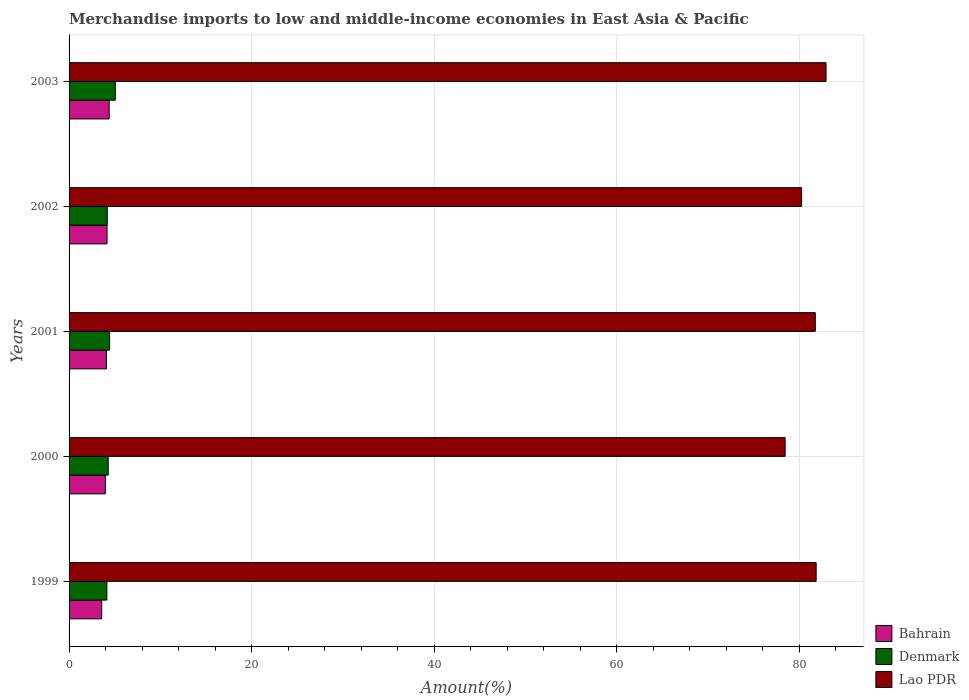How many different coloured bars are there?
Your response must be concise. 3. How many groups of bars are there?
Offer a very short reply. 5. Are the number of bars per tick equal to the number of legend labels?
Provide a short and direct response. Yes. How many bars are there on the 1st tick from the top?
Keep it short and to the point. 3. How many bars are there on the 2nd tick from the bottom?
Your answer should be very brief. 3. What is the percentage of amount earned from merchandise imports in Denmark in 2001?
Offer a terse response. 4.44. Across all years, what is the maximum percentage of amount earned from merchandise imports in Lao PDR?
Your response must be concise. 82.91. Across all years, what is the minimum percentage of amount earned from merchandise imports in Lao PDR?
Ensure brevity in your answer.  78.43. What is the total percentage of amount earned from merchandise imports in Denmark in the graph?
Your answer should be compact. 22.12. What is the difference between the percentage of amount earned from merchandise imports in Denmark in 2001 and that in 2002?
Provide a succinct answer. 0.26. What is the difference between the percentage of amount earned from merchandise imports in Denmark in 2003 and the percentage of amount earned from merchandise imports in Bahrain in 2002?
Provide a succinct answer. 0.91. What is the average percentage of amount earned from merchandise imports in Bahrain per year?
Offer a terse response. 4.04. In the year 1999, what is the difference between the percentage of amount earned from merchandise imports in Bahrain and percentage of amount earned from merchandise imports in Denmark?
Make the answer very short. -0.57. What is the ratio of the percentage of amount earned from merchandise imports in Bahrain in 2002 to that in 2003?
Make the answer very short. 0.95. Is the percentage of amount earned from merchandise imports in Lao PDR in 1999 less than that in 2003?
Keep it short and to the point. Yes. What is the difference between the highest and the second highest percentage of amount earned from merchandise imports in Bahrain?
Your answer should be very brief. 0.23. What is the difference between the highest and the lowest percentage of amount earned from merchandise imports in Bahrain?
Offer a terse response. 0.82. In how many years, is the percentage of amount earned from merchandise imports in Bahrain greater than the average percentage of amount earned from merchandise imports in Bahrain taken over all years?
Make the answer very short. 3. What does the 2nd bar from the top in 1999 represents?
Make the answer very short. Denmark. What does the 3rd bar from the bottom in 2002 represents?
Your answer should be very brief. Lao PDR. Are all the bars in the graph horizontal?
Your answer should be very brief. Yes. What is the difference between two consecutive major ticks on the X-axis?
Provide a short and direct response. 20. Are the values on the major ticks of X-axis written in scientific E-notation?
Offer a very short reply. No. How many legend labels are there?
Ensure brevity in your answer.  3. What is the title of the graph?
Make the answer very short. Merchandise imports to low and middle-income economies in East Asia & Pacific. What is the label or title of the X-axis?
Give a very brief answer. Amount(%). What is the Amount(%) of Bahrain in 1999?
Your answer should be compact. 3.57. What is the Amount(%) in Denmark in 1999?
Provide a succinct answer. 4.14. What is the Amount(%) of Lao PDR in 1999?
Give a very brief answer. 81.83. What is the Amount(%) in Bahrain in 2000?
Your response must be concise. 3.97. What is the Amount(%) in Denmark in 2000?
Make the answer very short. 4.29. What is the Amount(%) of Lao PDR in 2000?
Provide a short and direct response. 78.43. What is the Amount(%) of Bahrain in 2001?
Your answer should be very brief. 4.09. What is the Amount(%) of Denmark in 2001?
Provide a short and direct response. 4.44. What is the Amount(%) in Lao PDR in 2001?
Ensure brevity in your answer.  81.73. What is the Amount(%) in Bahrain in 2002?
Provide a short and direct response. 4.16. What is the Amount(%) of Denmark in 2002?
Provide a succinct answer. 4.18. What is the Amount(%) in Lao PDR in 2002?
Your answer should be compact. 80.23. What is the Amount(%) of Bahrain in 2003?
Offer a terse response. 4.39. What is the Amount(%) in Denmark in 2003?
Your answer should be very brief. 5.06. What is the Amount(%) in Lao PDR in 2003?
Your response must be concise. 82.91. Across all years, what is the maximum Amount(%) in Bahrain?
Offer a very short reply. 4.39. Across all years, what is the maximum Amount(%) of Denmark?
Your answer should be compact. 5.06. Across all years, what is the maximum Amount(%) of Lao PDR?
Offer a very short reply. 82.91. Across all years, what is the minimum Amount(%) in Bahrain?
Your response must be concise. 3.57. Across all years, what is the minimum Amount(%) in Denmark?
Your answer should be very brief. 4.14. Across all years, what is the minimum Amount(%) in Lao PDR?
Provide a short and direct response. 78.43. What is the total Amount(%) in Bahrain in the graph?
Your answer should be compact. 20.18. What is the total Amount(%) of Denmark in the graph?
Provide a succinct answer. 22.12. What is the total Amount(%) in Lao PDR in the graph?
Give a very brief answer. 405.13. What is the difference between the Amount(%) of Bahrain in 1999 and that in 2000?
Keep it short and to the point. -0.4. What is the difference between the Amount(%) in Denmark in 1999 and that in 2000?
Provide a succinct answer. -0.15. What is the difference between the Amount(%) in Lao PDR in 1999 and that in 2000?
Your answer should be compact. 3.4. What is the difference between the Amount(%) of Bahrain in 1999 and that in 2001?
Your answer should be very brief. -0.52. What is the difference between the Amount(%) in Denmark in 1999 and that in 2001?
Offer a very short reply. -0.3. What is the difference between the Amount(%) in Lao PDR in 1999 and that in 2001?
Keep it short and to the point. 0.09. What is the difference between the Amount(%) in Bahrain in 1999 and that in 2002?
Offer a terse response. -0.59. What is the difference between the Amount(%) of Denmark in 1999 and that in 2002?
Your response must be concise. -0.04. What is the difference between the Amount(%) in Lao PDR in 1999 and that in 2002?
Your answer should be very brief. 1.6. What is the difference between the Amount(%) of Bahrain in 1999 and that in 2003?
Your response must be concise. -0.82. What is the difference between the Amount(%) in Denmark in 1999 and that in 2003?
Your response must be concise. -0.92. What is the difference between the Amount(%) in Lao PDR in 1999 and that in 2003?
Your answer should be very brief. -1.08. What is the difference between the Amount(%) of Bahrain in 2000 and that in 2001?
Make the answer very short. -0.12. What is the difference between the Amount(%) in Denmark in 2000 and that in 2001?
Make the answer very short. -0.15. What is the difference between the Amount(%) in Lao PDR in 2000 and that in 2001?
Your answer should be compact. -3.31. What is the difference between the Amount(%) in Bahrain in 2000 and that in 2002?
Your response must be concise. -0.19. What is the difference between the Amount(%) of Denmark in 2000 and that in 2002?
Provide a short and direct response. 0.1. What is the difference between the Amount(%) in Lao PDR in 2000 and that in 2002?
Provide a succinct answer. -1.8. What is the difference between the Amount(%) in Bahrain in 2000 and that in 2003?
Provide a short and direct response. -0.42. What is the difference between the Amount(%) of Denmark in 2000 and that in 2003?
Your response must be concise. -0.78. What is the difference between the Amount(%) in Lao PDR in 2000 and that in 2003?
Make the answer very short. -4.48. What is the difference between the Amount(%) in Bahrain in 2001 and that in 2002?
Keep it short and to the point. -0.06. What is the difference between the Amount(%) in Denmark in 2001 and that in 2002?
Offer a very short reply. 0.26. What is the difference between the Amount(%) of Lao PDR in 2001 and that in 2002?
Provide a succinct answer. 1.5. What is the difference between the Amount(%) of Bahrain in 2001 and that in 2003?
Make the answer very short. -0.3. What is the difference between the Amount(%) in Denmark in 2001 and that in 2003?
Offer a very short reply. -0.62. What is the difference between the Amount(%) in Lao PDR in 2001 and that in 2003?
Ensure brevity in your answer.  -1.18. What is the difference between the Amount(%) in Bahrain in 2002 and that in 2003?
Offer a very short reply. -0.23. What is the difference between the Amount(%) of Denmark in 2002 and that in 2003?
Give a very brief answer. -0.88. What is the difference between the Amount(%) in Lao PDR in 2002 and that in 2003?
Your answer should be compact. -2.68. What is the difference between the Amount(%) of Bahrain in 1999 and the Amount(%) of Denmark in 2000?
Offer a terse response. -0.72. What is the difference between the Amount(%) in Bahrain in 1999 and the Amount(%) in Lao PDR in 2000?
Provide a succinct answer. -74.86. What is the difference between the Amount(%) of Denmark in 1999 and the Amount(%) of Lao PDR in 2000?
Provide a short and direct response. -74.29. What is the difference between the Amount(%) in Bahrain in 1999 and the Amount(%) in Denmark in 2001?
Provide a short and direct response. -0.87. What is the difference between the Amount(%) of Bahrain in 1999 and the Amount(%) of Lao PDR in 2001?
Offer a terse response. -78.16. What is the difference between the Amount(%) in Denmark in 1999 and the Amount(%) in Lao PDR in 2001?
Provide a short and direct response. -77.59. What is the difference between the Amount(%) of Bahrain in 1999 and the Amount(%) of Denmark in 2002?
Make the answer very short. -0.61. What is the difference between the Amount(%) in Bahrain in 1999 and the Amount(%) in Lao PDR in 2002?
Your answer should be compact. -76.66. What is the difference between the Amount(%) in Denmark in 1999 and the Amount(%) in Lao PDR in 2002?
Keep it short and to the point. -76.09. What is the difference between the Amount(%) in Bahrain in 1999 and the Amount(%) in Denmark in 2003?
Keep it short and to the point. -1.49. What is the difference between the Amount(%) in Bahrain in 1999 and the Amount(%) in Lao PDR in 2003?
Keep it short and to the point. -79.34. What is the difference between the Amount(%) in Denmark in 1999 and the Amount(%) in Lao PDR in 2003?
Provide a succinct answer. -78.77. What is the difference between the Amount(%) in Bahrain in 2000 and the Amount(%) in Denmark in 2001?
Offer a very short reply. -0.47. What is the difference between the Amount(%) in Bahrain in 2000 and the Amount(%) in Lao PDR in 2001?
Your answer should be very brief. -77.76. What is the difference between the Amount(%) of Denmark in 2000 and the Amount(%) of Lao PDR in 2001?
Your response must be concise. -77.45. What is the difference between the Amount(%) of Bahrain in 2000 and the Amount(%) of Denmark in 2002?
Give a very brief answer. -0.21. What is the difference between the Amount(%) in Bahrain in 2000 and the Amount(%) in Lao PDR in 2002?
Provide a short and direct response. -76.26. What is the difference between the Amount(%) of Denmark in 2000 and the Amount(%) of Lao PDR in 2002?
Offer a very short reply. -75.94. What is the difference between the Amount(%) of Bahrain in 2000 and the Amount(%) of Denmark in 2003?
Provide a short and direct response. -1.09. What is the difference between the Amount(%) in Bahrain in 2000 and the Amount(%) in Lao PDR in 2003?
Make the answer very short. -78.94. What is the difference between the Amount(%) in Denmark in 2000 and the Amount(%) in Lao PDR in 2003?
Give a very brief answer. -78.62. What is the difference between the Amount(%) of Bahrain in 2001 and the Amount(%) of Denmark in 2002?
Offer a very short reply. -0.09. What is the difference between the Amount(%) of Bahrain in 2001 and the Amount(%) of Lao PDR in 2002?
Ensure brevity in your answer.  -76.14. What is the difference between the Amount(%) of Denmark in 2001 and the Amount(%) of Lao PDR in 2002?
Make the answer very short. -75.79. What is the difference between the Amount(%) of Bahrain in 2001 and the Amount(%) of Denmark in 2003?
Provide a short and direct response. -0.97. What is the difference between the Amount(%) of Bahrain in 2001 and the Amount(%) of Lao PDR in 2003?
Your answer should be very brief. -78.82. What is the difference between the Amount(%) of Denmark in 2001 and the Amount(%) of Lao PDR in 2003?
Your answer should be very brief. -78.47. What is the difference between the Amount(%) in Bahrain in 2002 and the Amount(%) in Denmark in 2003?
Ensure brevity in your answer.  -0.91. What is the difference between the Amount(%) of Bahrain in 2002 and the Amount(%) of Lao PDR in 2003?
Provide a succinct answer. -78.75. What is the difference between the Amount(%) in Denmark in 2002 and the Amount(%) in Lao PDR in 2003?
Provide a short and direct response. -78.73. What is the average Amount(%) of Bahrain per year?
Keep it short and to the point. 4.04. What is the average Amount(%) of Denmark per year?
Provide a succinct answer. 4.42. What is the average Amount(%) of Lao PDR per year?
Ensure brevity in your answer.  81.03. In the year 1999, what is the difference between the Amount(%) in Bahrain and Amount(%) in Denmark?
Offer a terse response. -0.57. In the year 1999, what is the difference between the Amount(%) in Bahrain and Amount(%) in Lao PDR?
Provide a succinct answer. -78.26. In the year 1999, what is the difference between the Amount(%) of Denmark and Amount(%) of Lao PDR?
Provide a succinct answer. -77.69. In the year 2000, what is the difference between the Amount(%) of Bahrain and Amount(%) of Denmark?
Provide a short and direct response. -0.32. In the year 2000, what is the difference between the Amount(%) in Bahrain and Amount(%) in Lao PDR?
Your response must be concise. -74.46. In the year 2000, what is the difference between the Amount(%) of Denmark and Amount(%) of Lao PDR?
Offer a terse response. -74.14. In the year 2001, what is the difference between the Amount(%) of Bahrain and Amount(%) of Denmark?
Ensure brevity in your answer.  -0.35. In the year 2001, what is the difference between the Amount(%) in Bahrain and Amount(%) in Lao PDR?
Offer a terse response. -77.64. In the year 2001, what is the difference between the Amount(%) of Denmark and Amount(%) of Lao PDR?
Give a very brief answer. -77.29. In the year 2002, what is the difference between the Amount(%) in Bahrain and Amount(%) in Denmark?
Provide a short and direct response. -0.03. In the year 2002, what is the difference between the Amount(%) in Bahrain and Amount(%) in Lao PDR?
Keep it short and to the point. -76.07. In the year 2002, what is the difference between the Amount(%) of Denmark and Amount(%) of Lao PDR?
Make the answer very short. -76.05. In the year 2003, what is the difference between the Amount(%) in Bahrain and Amount(%) in Denmark?
Your answer should be very brief. -0.67. In the year 2003, what is the difference between the Amount(%) of Bahrain and Amount(%) of Lao PDR?
Your answer should be compact. -78.52. In the year 2003, what is the difference between the Amount(%) in Denmark and Amount(%) in Lao PDR?
Your response must be concise. -77.85. What is the ratio of the Amount(%) of Bahrain in 1999 to that in 2000?
Offer a very short reply. 0.9. What is the ratio of the Amount(%) in Denmark in 1999 to that in 2000?
Give a very brief answer. 0.97. What is the ratio of the Amount(%) in Lao PDR in 1999 to that in 2000?
Keep it short and to the point. 1.04. What is the ratio of the Amount(%) in Bahrain in 1999 to that in 2001?
Provide a succinct answer. 0.87. What is the ratio of the Amount(%) in Denmark in 1999 to that in 2001?
Keep it short and to the point. 0.93. What is the ratio of the Amount(%) of Bahrain in 1999 to that in 2002?
Offer a terse response. 0.86. What is the ratio of the Amount(%) of Lao PDR in 1999 to that in 2002?
Your response must be concise. 1.02. What is the ratio of the Amount(%) in Bahrain in 1999 to that in 2003?
Provide a short and direct response. 0.81. What is the ratio of the Amount(%) of Denmark in 1999 to that in 2003?
Keep it short and to the point. 0.82. What is the ratio of the Amount(%) in Lao PDR in 1999 to that in 2003?
Offer a very short reply. 0.99. What is the ratio of the Amount(%) of Bahrain in 2000 to that in 2001?
Your answer should be compact. 0.97. What is the ratio of the Amount(%) of Denmark in 2000 to that in 2001?
Give a very brief answer. 0.97. What is the ratio of the Amount(%) of Lao PDR in 2000 to that in 2001?
Offer a very short reply. 0.96. What is the ratio of the Amount(%) in Bahrain in 2000 to that in 2002?
Ensure brevity in your answer.  0.96. What is the ratio of the Amount(%) in Denmark in 2000 to that in 2002?
Keep it short and to the point. 1.02. What is the ratio of the Amount(%) in Lao PDR in 2000 to that in 2002?
Offer a terse response. 0.98. What is the ratio of the Amount(%) in Bahrain in 2000 to that in 2003?
Offer a terse response. 0.9. What is the ratio of the Amount(%) of Denmark in 2000 to that in 2003?
Make the answer very short. 0.85. What is the ratio of the Amount(%) of Lao PDR in 2000 to that in 2003?
Offer a very short reply. 0.95. What is the ratio of the Amount(%) in Bahrain in 2001 to that in 2002?
Offer a very short reply. 0.98. What is the ratio of the Amount(%) of Denmark in 2001 to that in 2002?
Keep it short and to the point. 1.06. What is the ratio of the Amount(%) in Lao PDR in 2001 to that in 2002?
Your answer should be compact. 1.02. What is the ratio of the Amount(%) of Bahrain in 2001 to that in 2003?
Offer a very short reply. 0.93. What is the ratio of the Amount(%) in Denmark in 2001 to that in 2003?
Keep it short and to the point. 0.88. What is the ratio of the Amount(%) of Lao PDR in 2001 to that in 2003?
Your answer should be very brief. 0.99. What is the ratio of the Amount(%) in Bahrain in 2002 to that in 2003?
Ensure brevity in your answer.  0.95. What is the ratio of the Amount(%) of Denmark in 2002 to that in 2003?
Your answer should be very brief. 0.83. What is the difference between the highest and the second highest Amount(%) of Bahrain?
Give a very brief answer. 0.23. What is the difference between the highest and the second highest Amount(%) in Denmark?
Offer a very short reply. 0.62. What is the difference between the highest and the second highest Amount(%) of Lao PDR?
Ensure brevity in your answer.  1.08. What is the difference between the highest and the lowest Amount(%) of Bahrain?
Offer a very short reply. 0.82. What is the difference between the highest and the lowest Amount(%) of Denmark?
Offer a very short reply. 0.92. What is the difference between the highest and the lowest Amount(%) of Lao PDR?
Give a very brief answer. 4.48. 